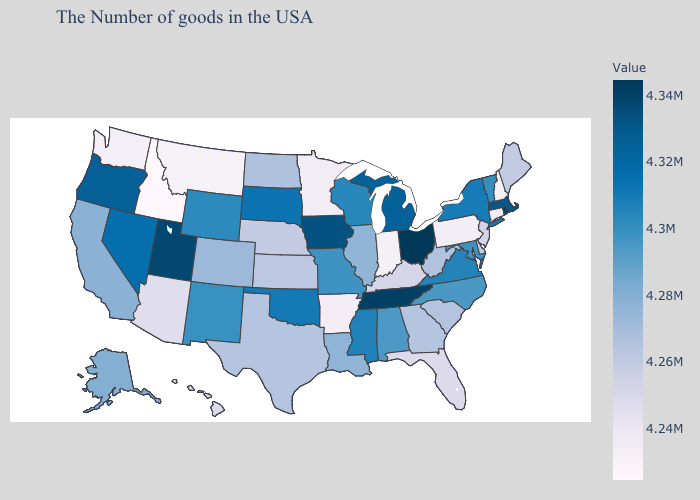Does Kentucky have the lowest value in the South?
Write a very short answer. No. Is the legend a continuous bar?
Give a very brief answer. Yes. Does the map have missing data?
Concise answer only. No. Among the states that border Illinois , which have the lowest value?
Quick response, please. Indiana. Does the map have missing data?
Write a very short answer. No. Does Rhode Island have the highest value in the Northeast?
Answer briefly. Yes. Among the states that border Georgia , does Florida have the lowest value?
Short answer required. Yes. 